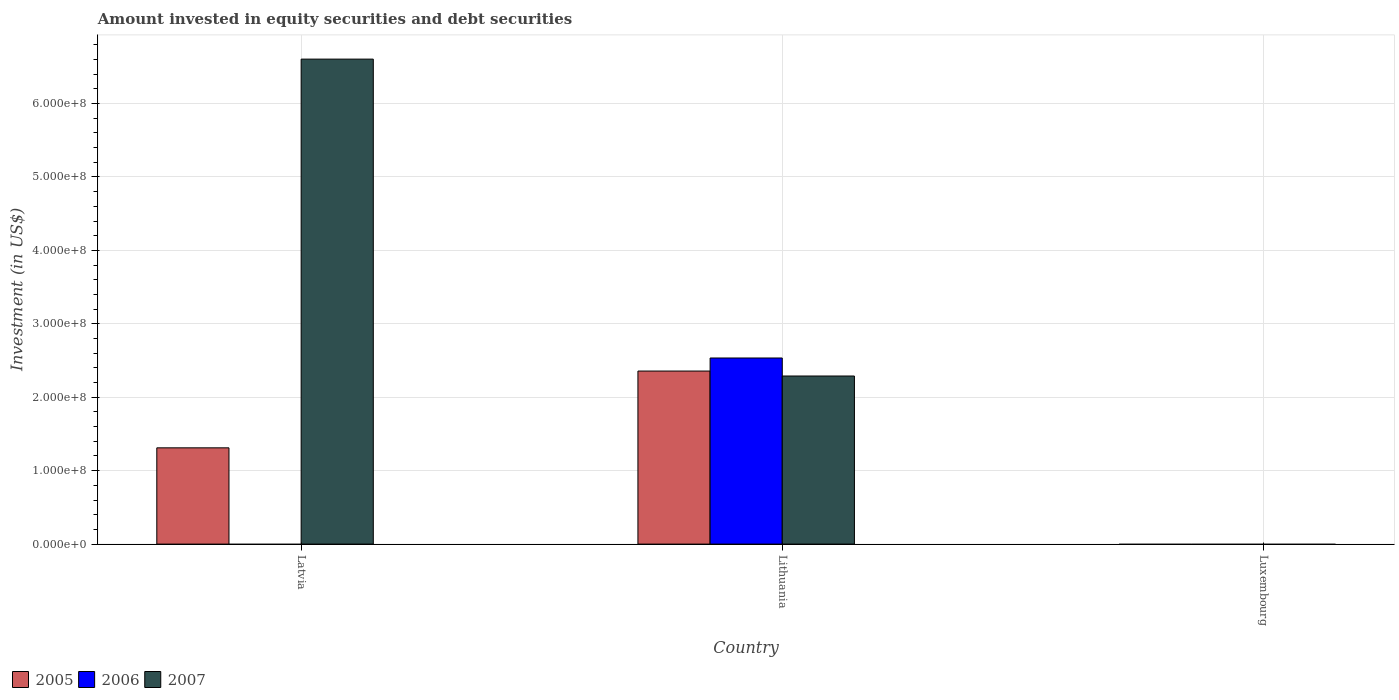How many different coloured bars are there?
Your answer should be compact. 3. Are the number of bars on each tick of the X-axis equal?
Your response must be concise. No. What is the label of the 1st group of bars from the left?
Ensure brevity in your answer.  Latvia. What is the amount invested in equity securities and debt securities in 2007 in Luxembourg?
Keep it short and to the point. 0. Across all countries, what is the maximum amount invested in equity securities and debt securities in 2006?
Your answer should be very brief. 2.53e+08. In which country was the amount invested in equity securities and debt securities in 2006 maximum?
Your answer should be compact. Lithuania. What is the total amount invested in equity securities and debt securities in 2006 in the graph?
Provide a succinct answer. 2.53e+08. What is the difference between the amount invested in equity securities and debt securities in 2007 in Latvia and that in Lithuania?
Your answer should be very brief. 4.32e+08. What is the difference between the amount invested in equity securities and debt securities in 2005 in Latvia and the amount invested in equity securities and debt securities in 2006 in Lithuania?
Provide a short and direct response. -1.22e+08. What is the average amount invested in equity securities and debt securities in 2007 per country?
Your answer should be compact. 2.96e+08. What is the difference between the amount invested in equity securities and debt securities of/in 2005 and amount invested in equity securities and debt securities of/in 2007 in Latvia?
Provide a short and direct response. -5.29e+08. Is the amount invested in equity securities and debt securities in 2007 in Latvia less than that in Lithuania?
Your answer should be compact. No. Is the difference between the amount invested in equity securities and debt securities in 2005 in Latvia and Lithuania greater than the difference between the amount invested in equity securities and debt securities in 2007 in Latvia and Lithuania?
Your answer should be very brief. No. What is the difference between the highest and the lowest amount invested in equity securities and debt securities in 2005?
Ensure brevity in your answer.  2.36e+08. Is the sum of the amount invested in equity securities and debt securities in 2007 in Latvia and Lithuania greater than the maximum amount invested in equity securities and debt securities in 2006 across all countries?
Keep it short and to the point. Yes. Is it the case that in every country, the sum of the amount invested in equity securities and debt securities in 2005 and amount invested in equity securities and debt securities in 2006 is greater than the amount invested in equity securities and debt securities in 2007?
Ensure brevity in your answer.  No. Are all the bars in the graph horizontal?
Offer a very short reply. No. How many countries are there in the graph?
Offer a terse response. 3. Are the values on the major ticks of Y-axis written in scientific E-notation?
Your answer should be compact. Yes. Does the graph contain grids?
Make the answer very short. Yes. What is the title of the graph?
Offer a very short reply. Amount invested in equity securities and debt securities. What is the label or title of the X-axis?
Keep it short and to the point. Country. What is the label or title of the Y-axis?
Offer a very short reply. Investment (in US$). What is the Investment (in US$) of 2005 in Latvia?
Offer a terse response. 1.31e+08. What is the Investment (in US$) in 2006 in Latvia?
Provide a short and direct response. 0. What is the Investment (in US$) in 2007 in Latvia?
Give a very brief answer. 6.60e+08. What is the Investment (in US$) of 2005 in Lithuania?
Offer a terse response. 2.36e+08. What is the Investment (in US$) in 2006 in Lithuania?
Make the answer very short. 2.53e+08. What is the Investment (in US$) of 2007 in Lithuania?
Offer a terse response. 2.29e+08. What is the Investment (in US$) of 2005 in Luxembourg?
Make the answer very short. 0. What is the Investment (in US$) in 2006 in Luxembourg?
Your response must be concise. 0. Across all countries, what is the maximum Investment (in US$) in 2005?
Offer a very short reply. 2.36e+08. Across all countries, what is the maximum Investment (in US$) in 2006?
Make the answer very short. 2.53e+08. Across all countries, what is the maximum Investment (in US$) in 2007?
Keep it short and to the point. 6.60e+08. Across all countries, what is the minimum Investment (in US$) in 2007?
Make the answer very short. 0. What is the total Investment (in US$) of 2005 in the graph?
Your answer should be compact. 3.67e+08. What is the total Investment (in US$) in 2006 in the graph?
Offer a terse response. 2.53e+08. What is the total Investment (in US$) of 2007 in the graph?
Make the answer very short. 8.89e+08. What is the difference between the Investment (in US$) in 2005 in Latvia and that in Lithuania?
Ensure brevity in your answer.  -1.05e+08. What is the difference between the Investment (in US$) of 2007 in Latvia and that in Lithuania?
Your response must be concise. 4.32e+08. What is the difference between the Investment (in US$) of 2005 in Latvia and the Investment (in US$) of 2006 in Lithuania?
Keep it short and to the point. -1.22e+08. What is the difference between the Investment (in US$) of 2005 in Latvia and the Investment (in US$) of 2007 in Lithuania?
Provide a succinct answer. -9.78e+07. What is the average Investment (in US$) in 2005 per country?
Give a very brief answer. 1.22e+08. What is the average Investment (in US$) of 2006 per country?
Offer a terse response. 8.45e+07. What is the average Investment (in US$) in 2007 per country?
Make the answer very short. 2.96e+08. What is the difference between the Investment (in US$) in 2005 and Investment (in US$) in 2007 in Latvia?
Keep it short and to the point. -5.29e+08. What is the difference between the Investment (in US$) in 2005 and Investment (in US$) in 2006 in Lithuania?
Provide a short and direct response. -1.78e+07. What is the difference between the Investment (in US$) of 2005 and Investment (in US$) of 2007 in Lithuania?
Your response must be concise. 6.75e+06. What is the difference between the Investment (in US$) in 2006 and Investment (in US$) in 2007 in Lithuania?
Provide a succinct answer. 2.45e+07. What is the ratio of the Investment (in US$) in 2005 in Latvia to that in Lithuania?
Provide a short and direct response. 0.56. What is the ratio of the Investment (in US$) in 2007 in Latvia to that in Lithuania?
Your answer should be compact. 2.89. What is the difference between the highest and the lowest Investment (in US$) of 2005?
Ensure brevity in your answer.  2.36e+08. What is the difference between the highest and the lowest Investment (in US$) of 2006?
Provide a succinct answer. 2.53e+08. What is the difference between the highest and the lowest Investment (in US$) of 2007?
Make the answer very short. 6.60e+08. 